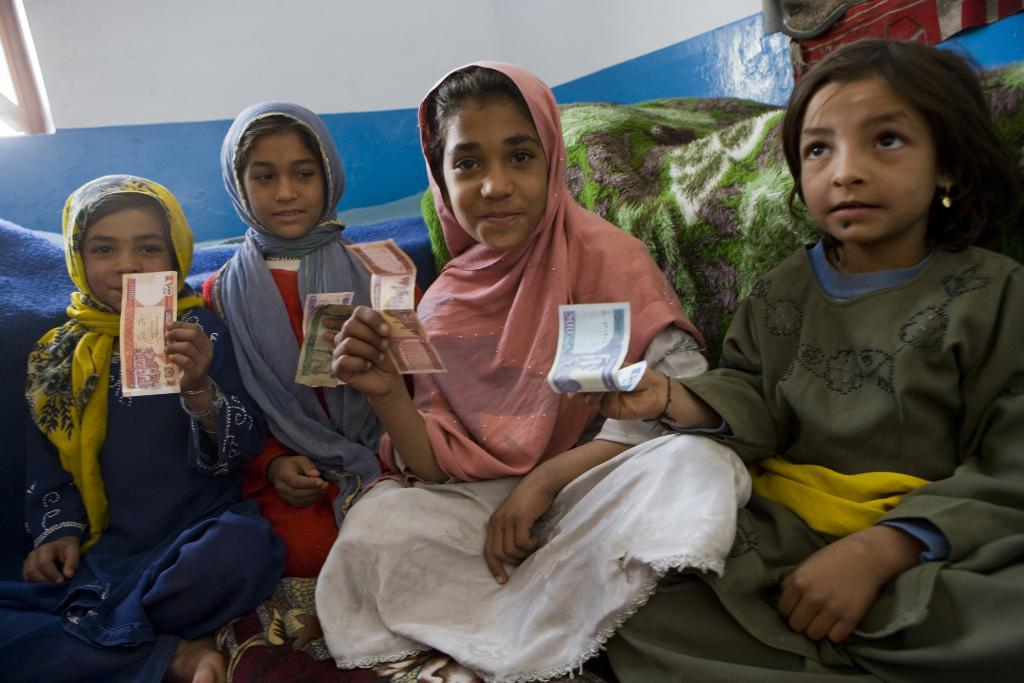How many children are present in the image? There are four children in the image. What are the children holding in the image? The children are holding a paper. What can be seen in the background of the image? Blankets are visible in the background of the image. What is the top of the image characterized by? The top of the image includes a wall. What type of jeans are the children wearing in the image? There is no mention of jeans in the image, so we cannot determine what type of jeans the children might be wearing. 